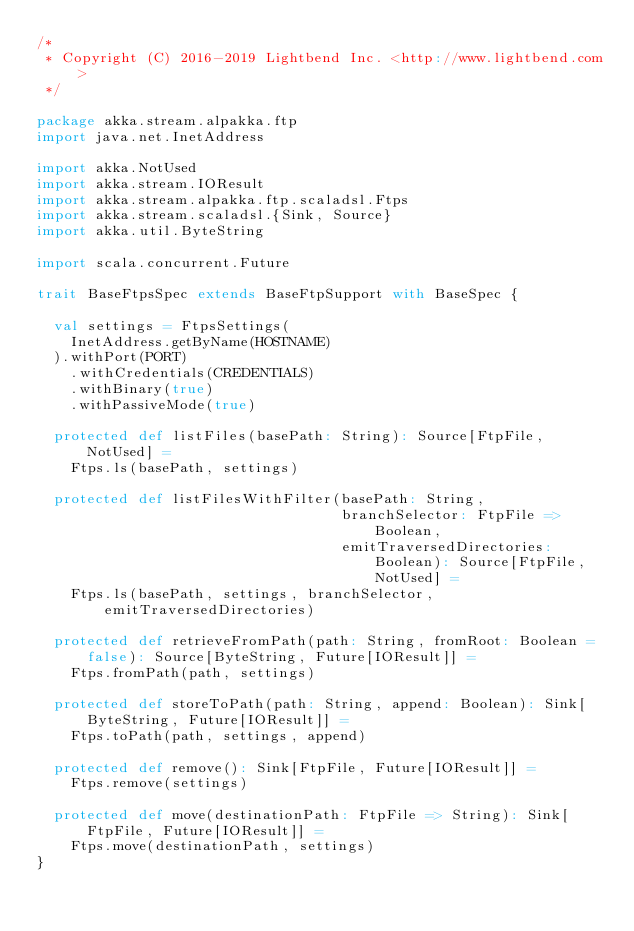<code> <loc_0><loc_0><loc_500><loc_500><_Scala_>/*
 * Copyright (C) 2016-2019 Lightbend Inc. <http://www.lightbend.com>
 */

package akka.stream.alpakka.ftp
import java.net.InetAddress

import akka.NotUsed
import akka.stream.IOResult
import akka.stream.alpakka.ftp.scaladsl.Ftps
import akka.stream.scaladsl.{Sink, Source}
import akka.util.ByteString

import scala.concurrent.Future

trait BaseFtpsSpec extends BaseFtpSupport with BaseSpec {

  val settings = FtpsSettings(
    InetAddress.getByName(HOSTNAME)
  ).withPort(PORT)
    .withCredentials(CREDENTIALS)
    .withBinary(true)
    .withPassiveMode(true)

  protected def listFiles(basePath: String): Source[FtpFile, NotUsed] =
    Ftps.ls(basePath, settings)

  protected def listFilesWithFilter(basePath: String,
                                    branchSelector: FtpFile => Boolean,
                                    emitTraversedDirectories: Boolean): Source[FtpFile, NotUsed] =
    Ftps.ls(basePath, settings, branchSelector, emitTraversedDirectories)

  protected def retrieveFromPath(path: String, fromRoot: Boolean = false): Source[ByteString, Future[IOResult]] =
    Ftps.fromPath(path, settings)

  protected def storeToPath(path: String, append: Boolean): Sink[ByteString, Future[IOResult]] =
    Ftps.toPath(path, settings, append)

  protected def remove(): Sink[FtpFile, Future[IOResult]] =
    Ftps.remove(settings)

  protected def move(destinationPath: FtpFile => String): Sink[FtpFile, Future[IOResult]] =
    Ftps.move(destinationPath, settings)
}
</code> 